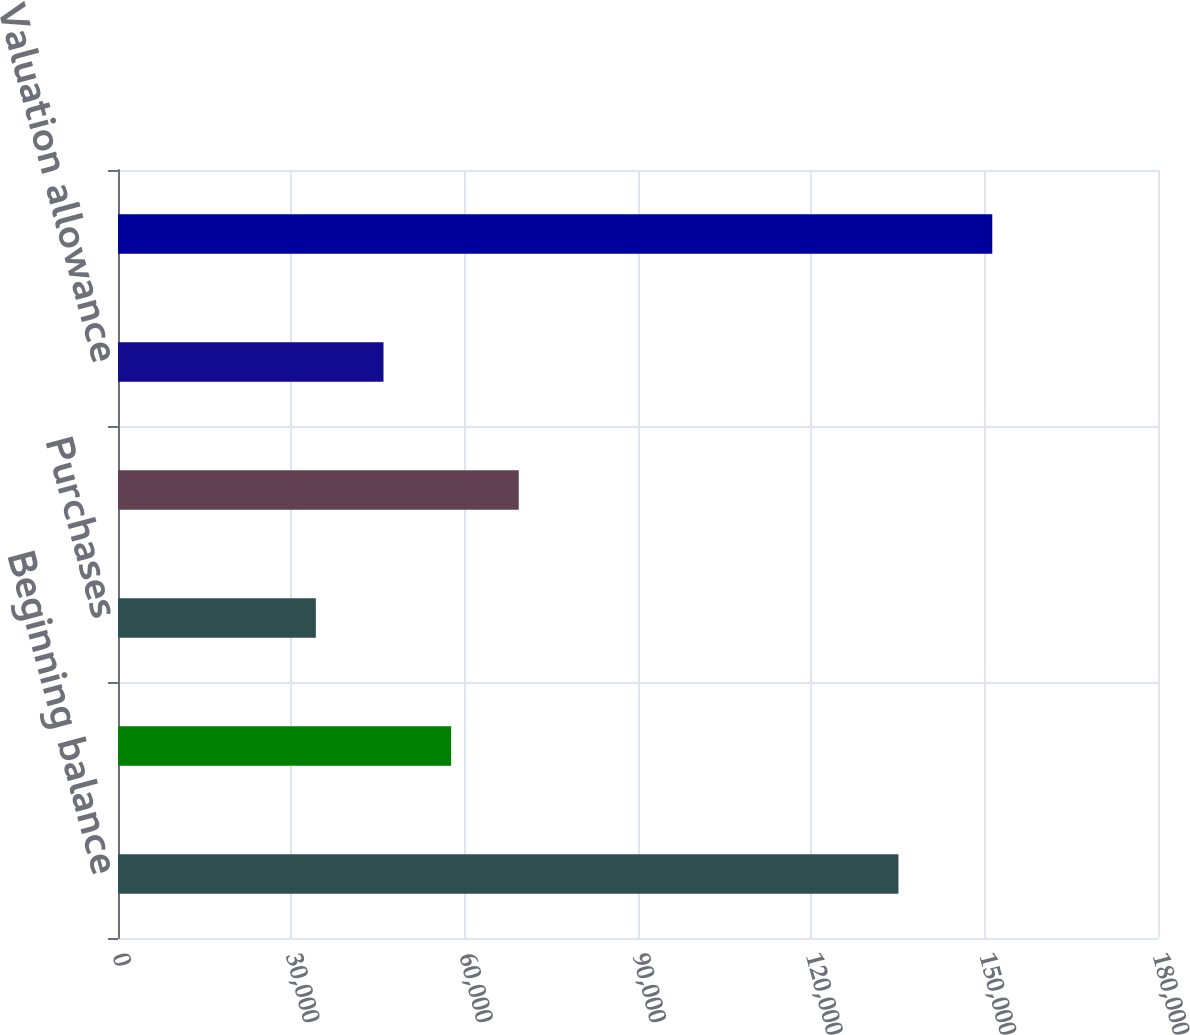<chart> <loc_0><loc_0><loc_500><loc_500><bar_chart><fcel>Beginning balance<fcel>Originations<fcel>Purchases<fcel>Amortization<fcel>Valuation allowance<fcel>Ending balance net<nl><fcel>135076<fcel>57657.6<fcel>34243<fcel>69364.9<fcel>45950.3<fcel>151316<nl></chart> 